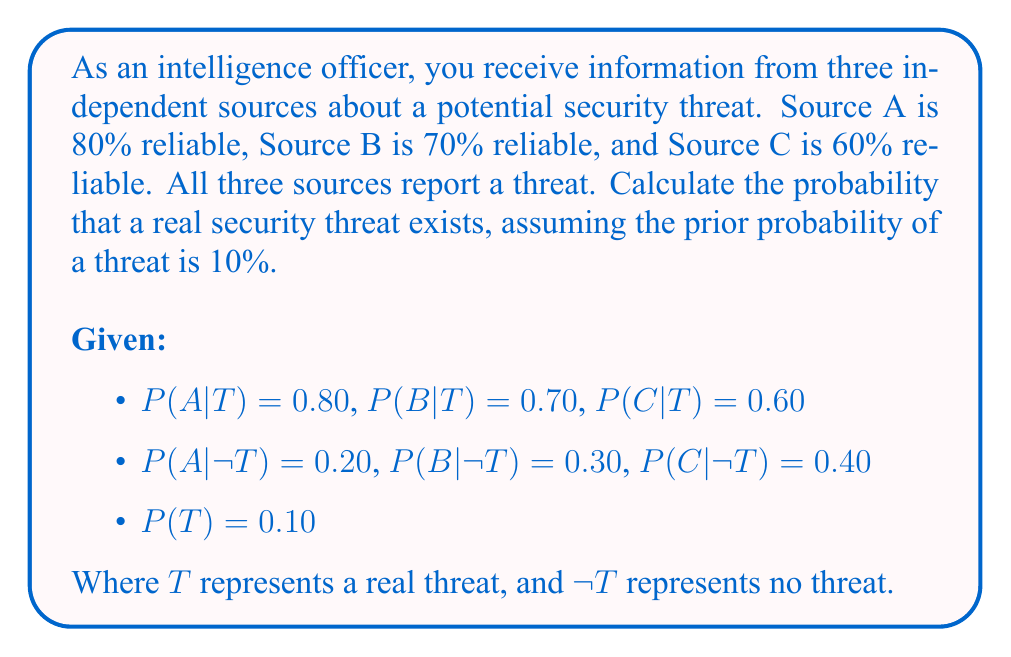Provide a solution to this math problem. To solve this problem, we'll use Bayes' Theorem and the concept of conditional probability.

Step 1: Define the event we're interested in
Let E be the event that all three sources report a threat.

Step 2: Apply Bayes' Theorem
$$P(T|E) = \frac{P(E|T) \cdot P(T)}{P(E)}$$

Step 3: Calculate P(E|T)
Since the sources are independent:
$$P(E|T) = P(A|T) \cdot P(B|T) \cdot P(C|T) = 0.80 \cdot 0.70 \cdot 0.60 = 0.336$$

Step 4: Calculate P(E|¬T)
$$P(E|¬T) = P(A|¬T) \cdot P(B|¬T) \cdot P(C|¬T) = 0.20 \cdot 0.30 \cdot 0.40 = 0.024$$

Step 5: Calculate P(E) using the law of total probability
$$P(E) = P(E|T) \cdot P(T) + P(E|¬T) \cdot P(¬T)$$
$$P(E) = 0.336 \cdot 0.10 + 0.024 \cdot 0.90 = 0.0336 + 0.0216 = 0.0552$$

Step 6: Apply Bayes' Theorem
$$P(T|E) = \frac{0.336 \cdot 0.10}{0.0552} = \frac{0.0336}{0.0552} \approx 0.6087$$

Therefore, the probability of a real security threat given that all three sources report a threat is approximately 0.6087 or 60.87%.
Answer: 0.6087 (or 60.87%) 